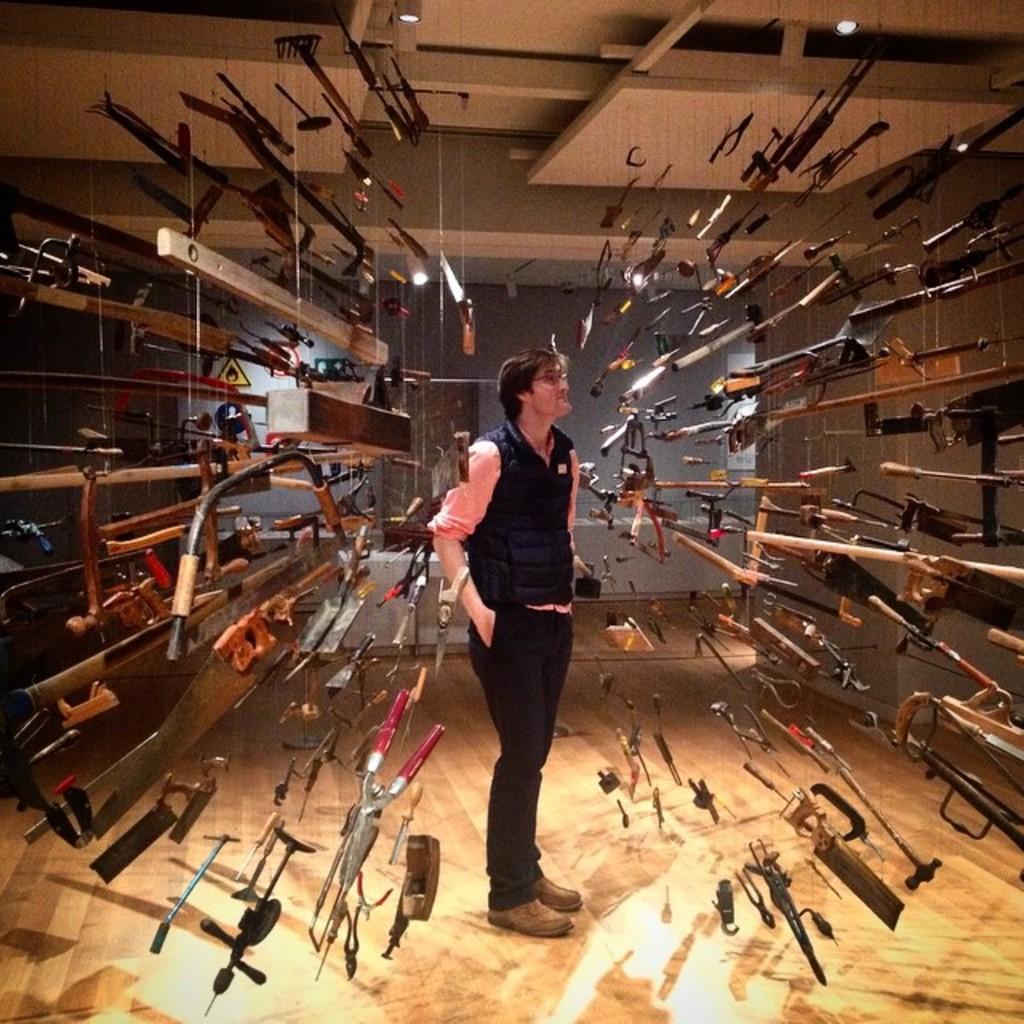In one or two sentences, can you explain what this image depicts? This picture is clicked inside the room. In the center we can see a person standing on the floor and on both the sides we can see many number of tools hanging on the roof. At the top we can see the ceiling lights. In the background we can see the wall and some other objects. 